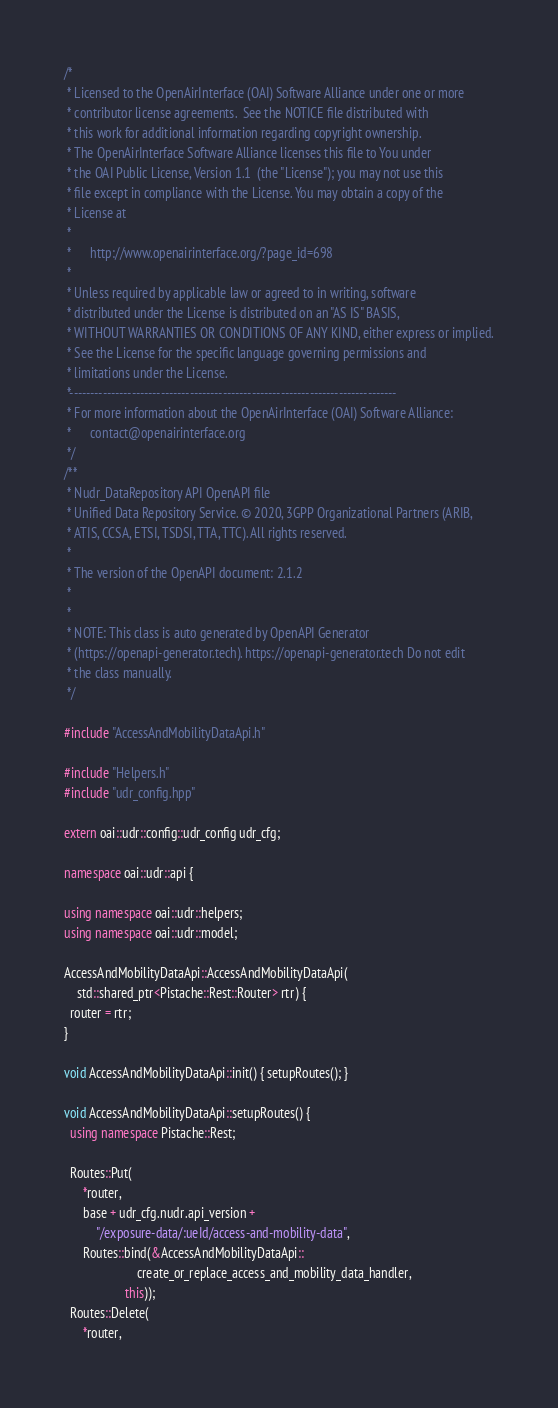<code> <loc_0><loc_0><loc_500><loc_500><_C++_>/*
 * Licensed to the OpenAirInterface (OAI) Software Alliance under one or more
 * contributor license agreements.  See the NOTICE file distributed with
 * this work for additional information regarding copyright ownership.
 * The OpenAirInterface Software Alliance licenses this file to You under
 * the OAI Public License, Version 1.1  (the "License"); you may not use this
 * file except in compliance with the License. You may obtain a copy of the
 * License at
 *
 *      http://www.openairinterface.org/?page_id=698
 *
 * Unless required by applicable law or agreed to in writing, software
 * distributed under the License is distributed on an "AS IS" BASIS,
 * WITHOUT WARRANTIES OR CONDITIONS OF ANY KIND, either express or implied.
 * See the License for the specific language governing permissions and
 * limitations under the License.
 *-------------------------------------------------------------------------------
 * For more information about the OpenAirInterface (OAI) Software Alliance:
 *      contact@openairinterface.org
 */
/**
 * Nudr_DataRepository API OpenAPI file
 * Unified Data Repository Service. © 2020, 3GPP Organizational Partners (ARIB,
 * ATIS, CCSA, ETSI, TSDSI, TTA, TTC). All rights reserved.
 *
 * The version of the OpenAPI document: 2.1.2
 *
 *
 * NOTE: This class is auto generated by OpenAPI Generator
 * (https://openapi-generator.tech). https://openapi-generator.tech Do not edit
 * the class manually.
 */

#include "AccessAndMobilityDataApi.h"

#include "Helpers.h"
#include "udr_config.hpp"

extern oai::udr::config::udr_config udr_cfg;

namespace oai::udr::api {

using namespace oai::udr::helpers;
using namespace oai::udr::model;

AccessAndMobilityDataApi::AccessAndMobilityDataApi(
    std::shared_ptr<Pistache::Rest::Router> rtr) {
  router = rtr;
}

void AccessAndMobilityDataApi::init() { setupRoutes(); }

void AccessAndMobilityDataApi::setupRoutes() {
  using namespace Pistache::Rest;

  Routes::Put(
      *router,
      base + udr_cfg.nudr.api_version +
          "/exposure-data/:ueId/access-and-mobility-data",
      Routes::bind(&AccessAndMobilityDataApi::
                       create_or_replace_access_and_mobility_data_handler,
                   this));
  Routes::Delete(
      *router,</code> 